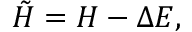Convert formula to latex. <formula><loc_0><loc_0><loc_500><loc_500>\tilde { H } = H - \Delta E ,</formula> 